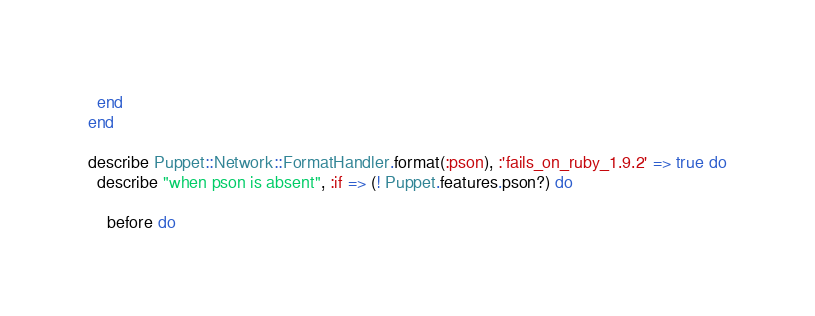<code> <loc_0><loc_0><loc_500><loc_500><_Ruby_>  end
end

describe Puppet::Network::FormatHandler.format(:pson), :'fails_on_ruby_1.9.2' => true do
  describe "when pson is absent", :if => (! Puppet.features.pson?) do

    before do</code> 